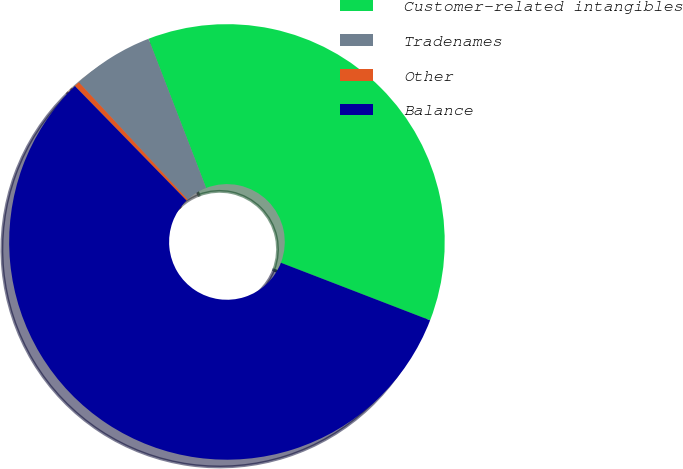Convert chart. <chart><loc_0><loc_0><loc_500><loc_500><pie_chart><fcel>Customer-related intangibles<fcel>Tradenames<fcel>Other<fcel>Balance<nl><fcel>36.72%<fcel>6.04%<fcel>0.4%<fcel>56.83%<nl></chart> 